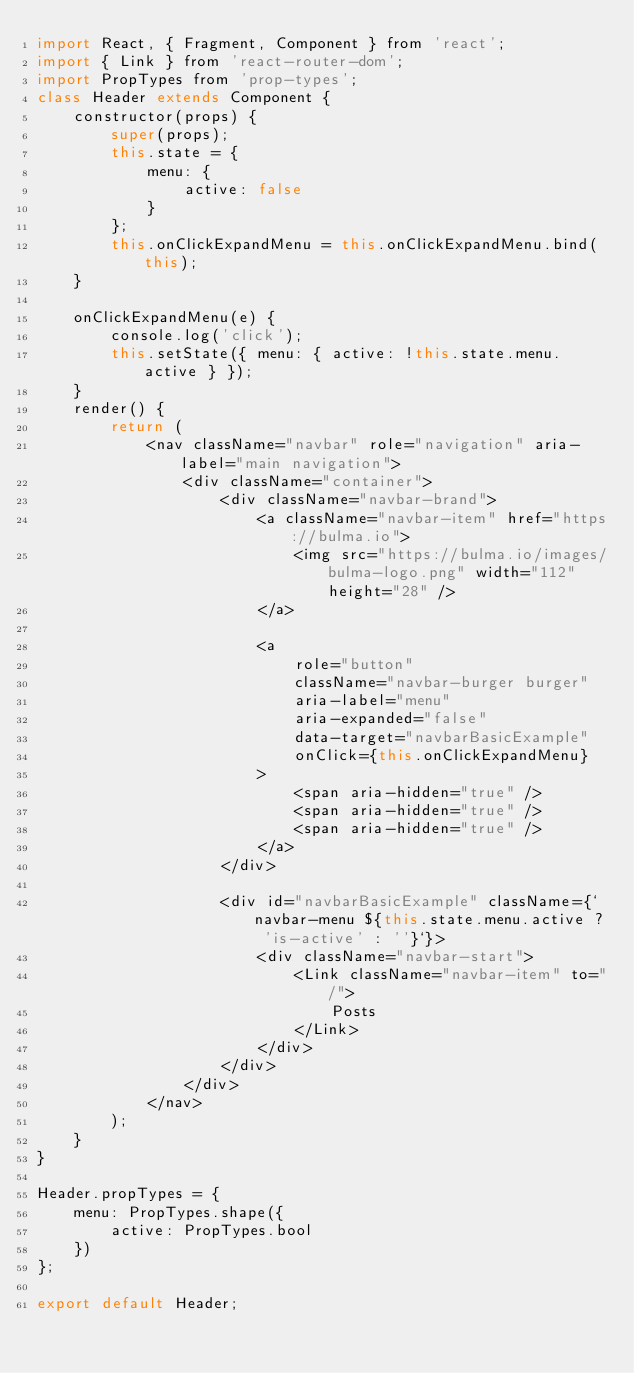Convert code to text. <code><loc_0><loc_0><loc_500><loc_500><_JavaScript_>import React, { Fragment, Component } from 'react';
import { Link } from 'react-router-dom';
import PropTypes from 'prop-types';
class Header extends Component {
	constructor(props) {
		super(props);
		this.state = {
			menu: {
				active: false
			}
		};
		this.onClickExpandMenu = this.onClickExpandMenu.bind(this);
	}

	onClickExpandMenu(e) {
		console.log('click');
		this.setState({ menu: { active: !this.state.menu.active } });
	}
	render() {
		return (
			<nav className="navbar" role="navigation" aria-label="main navigation">
				<div className="container">
					<div className="navbar-brand">
						<a className="navbar-item" href="https://bulma.io">
							<img src="https://bulma.io/images/bulma-logo.png" width="112" height="28" />
						</a>

						<a
							role="button"
							className="navbar-burger burger"
							aria-label="menu"
							aria-expanded="false"
							data-target="navbarBasicExample"
							onClick={this.onClickExpandMenu}
						>
							<span aria-hidden="true" />
							<span aria-hidden="true" />
							<span aria-hidden="true" />
						</a>
					</div>

					<div id="navbarBasicExample" className={`navbar-menu ${this.state.menu.active ? 'is-active' : ''}`}>
						<div className="navbar-start">
							<Link className="navbar-item" to="/">
								Posts
							</Link>
						</div>
					</div>
				</div>
			</nav>
		);
	}
}

Header.propTypes = {
	menu: PropTypes.shape({
		active: PropTypes.bool
	})
};

export default Header;
</code> 